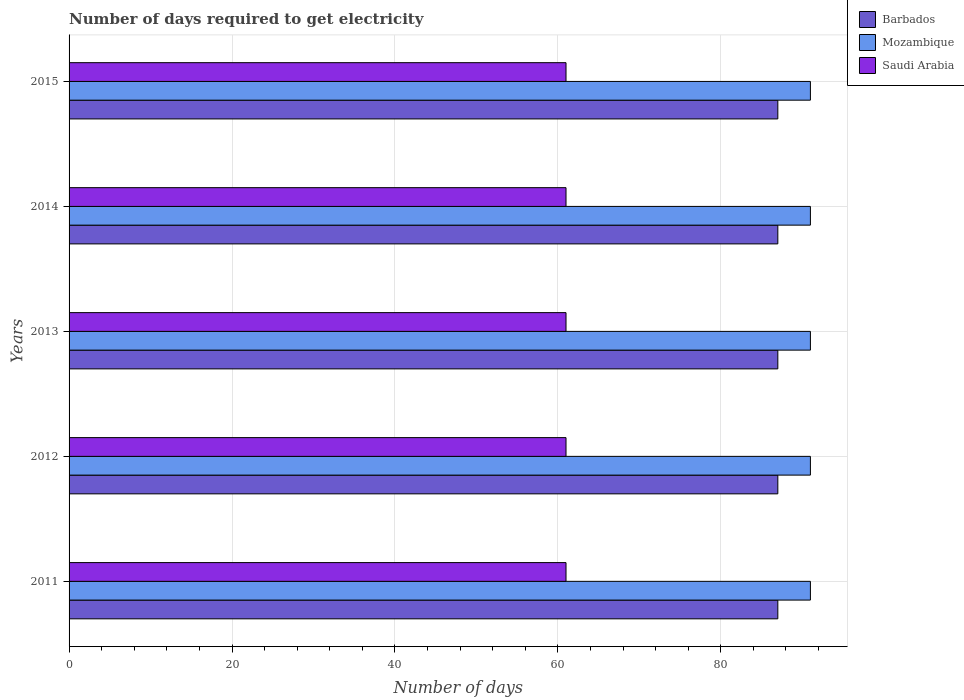Are the number of bars per tick equal to the number of legend labels?
Your answer should be compact. Yes. How many bars are there on the 5th tick from the top?
Make the answer very short. 3. How many bars are there on the 2nd tick from the bottom?
Provide a short and direct response. 3. What is the number of days required to get electricity in in Saudi Arabia in 2015?
Provide a succinct answer. 61. Across all years, what is the maximum number of days required to get electricity in in Saudi Arabia?
Provide a succinct answer. 61. Across all years, what is the minimum number of days required to get electricity in in Mozambique?
Provide a succinct answer. 91. In which year was the number of days required to get electricity in in Saudi Arabia maximum?
Your answer should be very brief. 2011. In which year was the number of days required to get electricity in in Barbados minimum?
Keep it short and to the point. 2011. What is the total number of days required to get electricity in in Barbados in the graph?
Keep it short and to the point. 435. What is the difference between the number of days required to get electricity in in Saudi Arabia in 2012 and that in 2015?
Your answer should be very brief. 0. What is the average number of days required to get electricity in in Barbados per year?
Offer a terse response. 87. In the year 2011, what is the difference between the number of days required to get electricity in in Mozambique and number of days required to get electricity in in Barbados?
Provide a short and direct response. 4. Is the difference between the number of days required to get electricity in in Mozambique in 2012 and 2014 greater than the difference between the number of days required to get electricity in in Barbados in 2012 and 2014?
Your answer should be compact. No. What is the difference between the highest and the second highest number of days required to get electricity in in Mozambique?
Your answer should be compact. 0. Is the sum of the number of days required to get electricity in in Mozambique in 2012 and 2014 greater than the maximum number of days required to get electricity in in Barbados across all years?
Your response must be concise. Yes. What does the 2nd bar from the top in 2013 represents?
Your response must be concise. Mozambique. What does the 2nd bar from the bottom in 2013 represents?
Provide a succinct answer. Mozambique. Is it the case that in every year, the sum of the number of days required to get electricity in in Mozambique and number of days required to get electricity in in Barbados is greater than the number of days required to get electricity in in Saudi Arabia?
Your response must be concise. Yes. What is the title of the graph?
Provide a short and direct response. Number of days required to get electricity. Does "Liberia" appear as one of the legend labels in the graph?
Offer a terse response. No. What is the label or title of the X-axis?
Provide a succinct answer. Number of days. What is the Number of days of Barbados in 2011?
Offer a terse response. 87. What is the Number of days of Mozambique in 2011?
Your answer should be very brief. 91. What is the Number of days of Saudi Arabia in 2011?
Make the answer very short. 61. What is the Number of days in Mozambique in 2012?
Offer a terse response. 91. What is the Number of days of Barbados in 2013?
Keep it short and to the point. 87. What is the Number of days in Mozambique in 2013?
Offer a very short reply. 91. What is the Number of days of Saudi Arabia in 2013?
Ensure brevity in your answer.  61. What is the Number of days in Barbados in 2014?
Give a very brief answer. 87. What is the Number of days in Mozambique in 2014?
Your response must be concise. 91. What is the Number of days in Saudi Arabia in 2014?
Ensure brevity in your answer.  61. What is the Number of days in Barbados in 2015?
Make the answer very short. 87. What is the Number of days of Mozambique in 2015?
Make the answer very short. 91. Across all years, what is the maximum Number of days in Barbados?
Ensure brevity in your answer.  87. Across all years, what is the maximum Number of days of Mozambique?
Your response must be concise. 91. Across all years, what is the minimum Number of days in Mozambique?
Keep it short and to the point. 91. Across all years, what is the minimum Number of days in Saudi Arabia?
Your response must be concise. 61. What is the total Number of days of Barbados in the graph?
Your answer should be compact. 435. What is the total Number of days in Mozambique in the graph?
Ensure brevity in your answer.  455. What is the total Number of days in Saudi Arabia in the graph?
Provide a short and direct response. 305. What is the difference between the Number of days in Barbados in 2011 and that in 2012?
Keep it short and to the point. 0. What is the difference between the Number of days of Saudi Arabia in 2011 and that in 2012?
Ensure brevity in your answer.  0. What is the difference between the Number of days of Barbados in 2011 and that in 2013?
Make the answer very short. 0. What is the difference between the Number of days in Barbados in 2011 and that in 2014?
Provide a short and direct response. 0. What is the difference between the Number of days in Mozambique in 2011 and that in 2014?
Your answer should be compact. 0. What is the difference between the Number of days in Saudi Arabia in 2011 and that in 2014?
Offer a very short reply. 0. What is the difference between the Number of days in Barbados in 2011 and that in 2015?
Your answer should be compact. 0. What is the difference between the Number of days in Saudi Arabia in 2011 and that in 2015?
Your answer should be compact. 0. What is the difference between the Number of days of Saudi Arabia in 2012 and that in 2013?
Make the answer very short. 0. What is the difference between the Number of days in Barbados in 2012 and that in 2014?
Give a very brief answer. 0. What is the difference between the Number of days of Mozambique in 2012 and that in 2014?
Offer a very short reply. 0. What is the difference between the Number of days of Mozambique in 2013 and that in 2014?
Your answer should be compact. 0. What is the difference between the Number of days of Saudi Arabia in 2013 and that in 2015?
Your answer should be compact. 0. What is the difference between the Number of days of Barbados in 2014 and that in 2015?
Your answer should be compact. 0. What is the difference between the Number of days in Barbados in 2011 and the Number of days in Saudi Arabia in 2013?
Your response must be concise. 26. What is the difference between the Number of days in Barbados in 2011 and the Number of days in Mozambique in 2014?
Ensure brevity in your answer.  -4. What is the difference between the Number of days of Barbados in 2012 and the Number of days of Mozambique in 2014?
Your answer should be very brief. -4. What is the difference between the Number of days of Barbados in 2012 and the Number of days of Saudi Arabia in 2014?
Ensure brevity in your answer.  26. What is the difference between the Number of days in Mozambique in 2012 and the Number of days in Saudi Arabia in 2014?
Give a very brief answer. 30. What is the difference between the Number of days in Barbados in 2012 and the Number of days in Mozambique in 2015?
Make the answer very short. -4. What is the difference between the Number of days of Barbados in 2013 and the Number of days of Mozambique in 2014?
Give a very brief answer. -4. What is the difference between the Number of days of Barbados in 2013 and the Number of days of Saudi Arabia in 2014?
Provide a short and direct response. 26. What is the difference between the Number of days of Mozambique in 2013 and the Number of days of Saudi Arabia in 2014?
Give a very brief answer. 30. What is the difference between the Number of days of Barbados in 2013 and the Number of days of Mozambique in 2015?
Ensure brevity in your answer.  -4. What is the difference between the Number of days of Barbados in 2013 and the Number of days of Saudi Arabia in 2015?
Ensure brevity in your answer.  26. What is the difference between the Number of days of Barbados in 2014 and the Number of days of Mozambique in 2015?
Give a very brief answer. -4. What is the difference between the Number of days in Barbados in 2014 and the Number of days in Saudi Arabia in 2015?
Give a very brief answer. 26. What is the average Number of days in Barbados per year?
Offer a very short reply. 87. What is the average Number of days in Mozambique per year?
Your answer should be very brief. 91. In the year 2011, what is the difference between the Number of days in Barbados and Number of days in Saudi Arabia?
Offer a terse response. 26. In the year 2012, what is the difference between the Number of days in Barbados and Number of days in Mozambique?
Offer a terse response. -4. In the year 2012, what is the difference between the Number of days of Mozambique and Number of days of Saudi Arabia?
Offer a terse response. 30. In the year 2015, what is the difference between the Number of days of Barbados and Number of days of Mozambique?
Give a very brief answer. -4. In the year 2015, what is the difference between the Number of days of Barbados and Number of days of Saudi Arabia?
Provide a succinct answer. 26. In the year 2015, what is the difference between the Number of days of Mozambique and Number of days of Saudi Arabia?
Give a very brief answer. 30. What is the ratio of the Number of days in Mozambique in 2011 to that in 2012?
Offer a terse response. 1. What is the ratio of the Number of days of Saudi Arabia in 2011 to that in 2012?
Offer a very short reply. 1. What is the ratio of the Number of days in Mozambique in 2011 to that in 2013?
Provide a short and direct response. 1. What is the ratio of the Number of days of Mozambique in 2011 to that in 2014?
Offer a very short reply. 1. What is the ratio of the Number of days of Mozambique in 2011 to that in 2015?
Give a very brief answer. 1. What is the ratio of the Number of days in Saudi Arabia in 2011 to that in 2015?
Offer a terse response. 1. What is the ratio of the Number of days in Barbados in 2012 to that in 2013?
Make the answer very short. 1. What is the ratio of the Number of days of Saudi Arabia in 2012 to that in 2013?
Keep it short and to the point. 1. What is the ratio of the Number of days in Mozambique in 2012 to that in 2014?
Give a very brief answer. 1. What is the ratio of the Number of days in Saudi Arabia in 2012 to that in 2014?
Keep it short and to the point. 1. What is the ratio of the Number of days in Barbados in 2012 to that in 2015?
Provide a succinct answer. 1. What is the ratio of the Number of days of Saudi Arabia in 2012 to that in 2015?
Offer a very short reply. 1. What is the ratio of the Number of days in Saudi Arabia in 2013 to that in 2014?
Your response must be concise. 1. What is the ratio of the Number of days of Barbados in 2013 to that in 2015?
Keep it short and to the point. 1. What is the ratio of the Number of days of Mozambique in 2013 to that in 2015?
Provide a succinct answer. 1. What is the ratio of the Number of days of Saudi Arabia in 2013 to that in 2015?
Offer a terse response. 1. What is the ratio of the Number of days in Barbados in 2014 to that in 2015?
Ensure brevity in your answer.  1. What is the ratio of the Number of days in Mozambique in 2014 to that in 2015?
Make the answer very short. 1. What is the difference between the highest and the second highest Number of days in Barbados?
Offer a terse response. 0. What is the difference between the highest and the second highest Number of days of Mozambique?
Your answer should be compact. 0. What is the difference between the highest and the lowest Number of days of Mozambique?
Offer a terse response. 0. What is the difference between the highest and the lowest Number of days of Saudi Arabia?
Your answer should be compact. 0. 